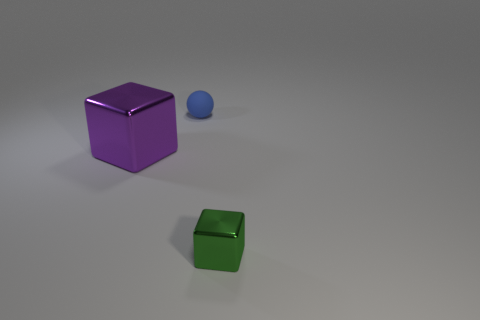The other thing that is the same shape as the small green thing is what size?
Offer a terse response. Large. How many things are either blue things behind the tiny green metallic cube or shiny blocks right of the large metallic block?
Your response must be concise. 2. What is the shape of the shiny thing behind the metallic block that is to the right of the purple block?
Your answer should be very brief. Cube. Are there any other things that have the same color as the big block?
Ensure brevity in your answer.  No. Is there any other thing that has the same size as the blue ball?
Provide a succinct answer. Yes. How many objects are big cubes or large purple shiny spheres?
Offer a terse response. 1. Are there any other blue matte objects of the same size as the blue matte object?
Offer a terse response. No. The blue matte thing has what shape?
Ensure brevity in your answer.  Sphere. Is the number of tiny metal things to the left of the small matte sphere greater than the number of green metal cubes that are behind the green metal block?
Give a very brief answer. No. Do the metal cube that is right of the big object and the thing that is behind the big purple shiny thing have the same color?
Give a very brief answer. No. 